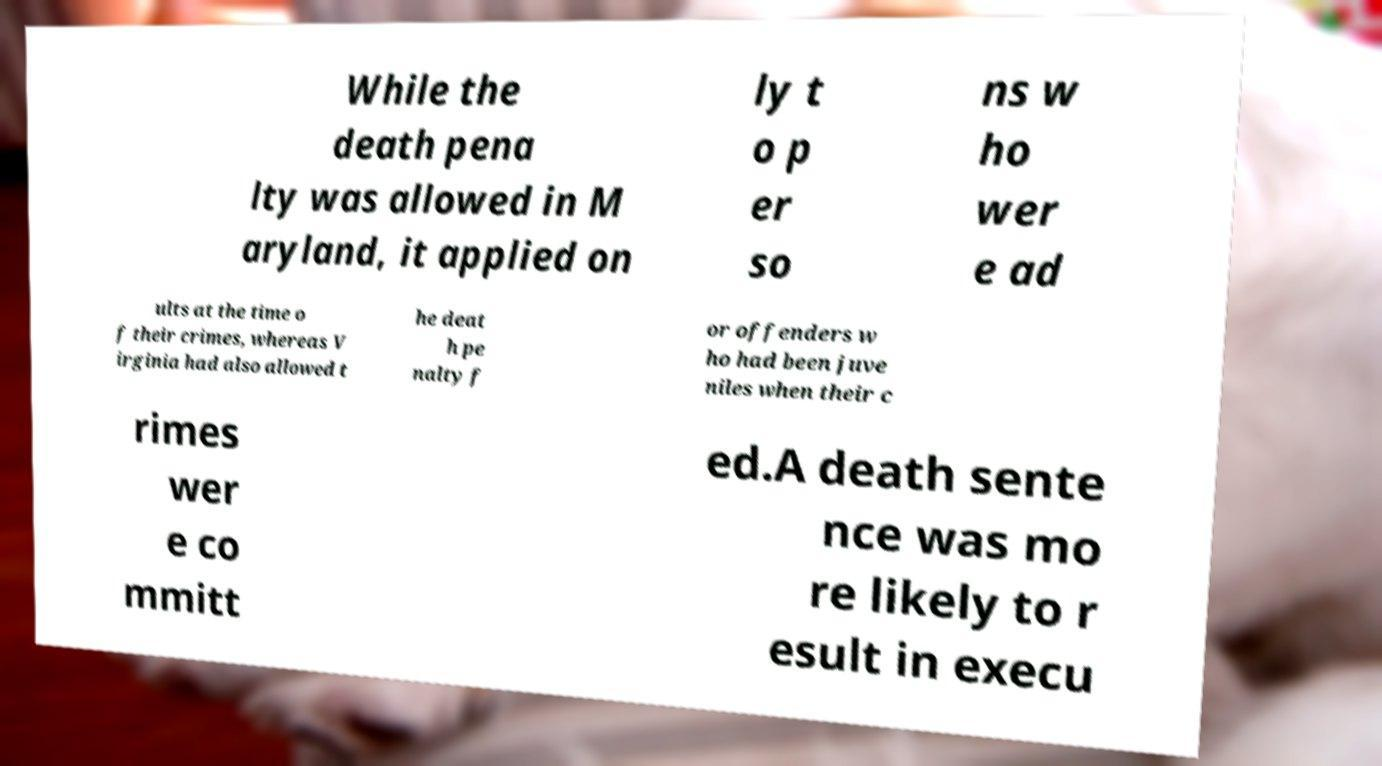I need the written content from this picture converted into text. Can you do that? While the death pena lty was allowed in M aryland, it applied on ly t o p er so ns w ho wer e ad ults at the time o f their crimes, whereas V irginia had also allowed t he deat h pe nalty f or offenders w ho had been juve niles when their c rimes wer e co mmitt ed.A death sente nce was mo re likely to r esult in execu 